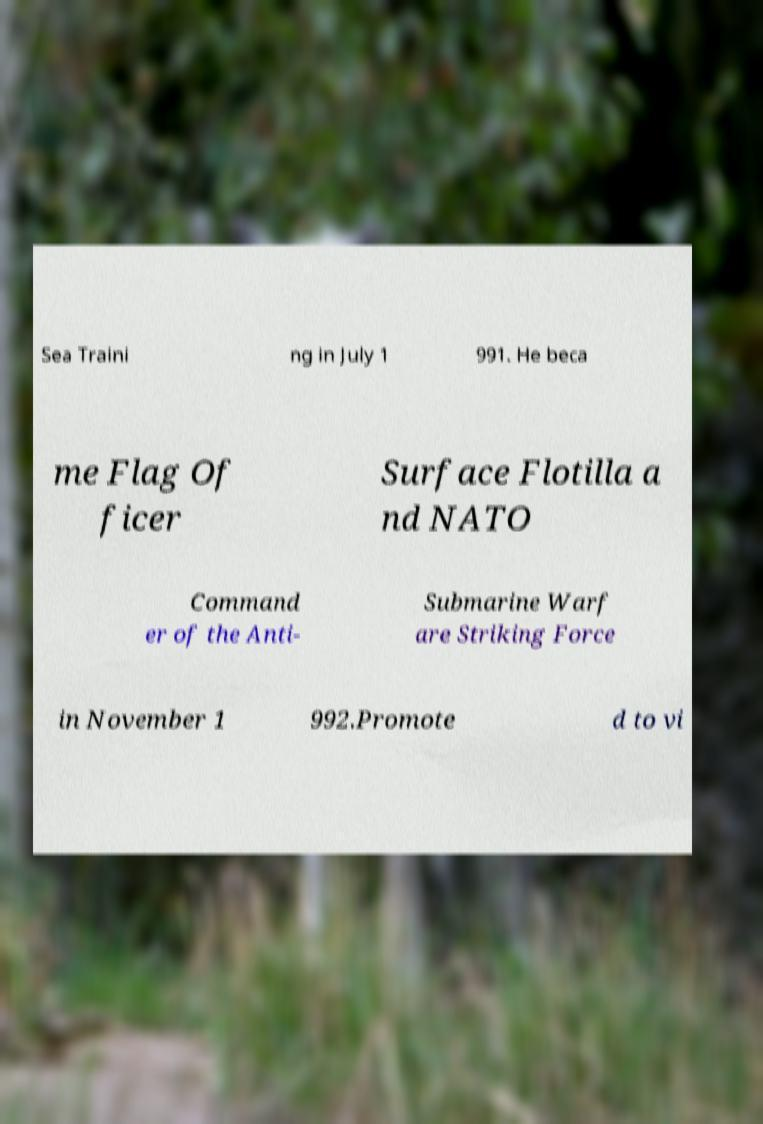What messages or text are displayed in this image? I need them in a readable, typed format. Sea Traini ng in July 1 991. He beca me Flag Of ficer Surface Flotilla a nd NATO Command er of the Anti- Submarine Warf are Striking Force in November 1 992.Promote d to vi 